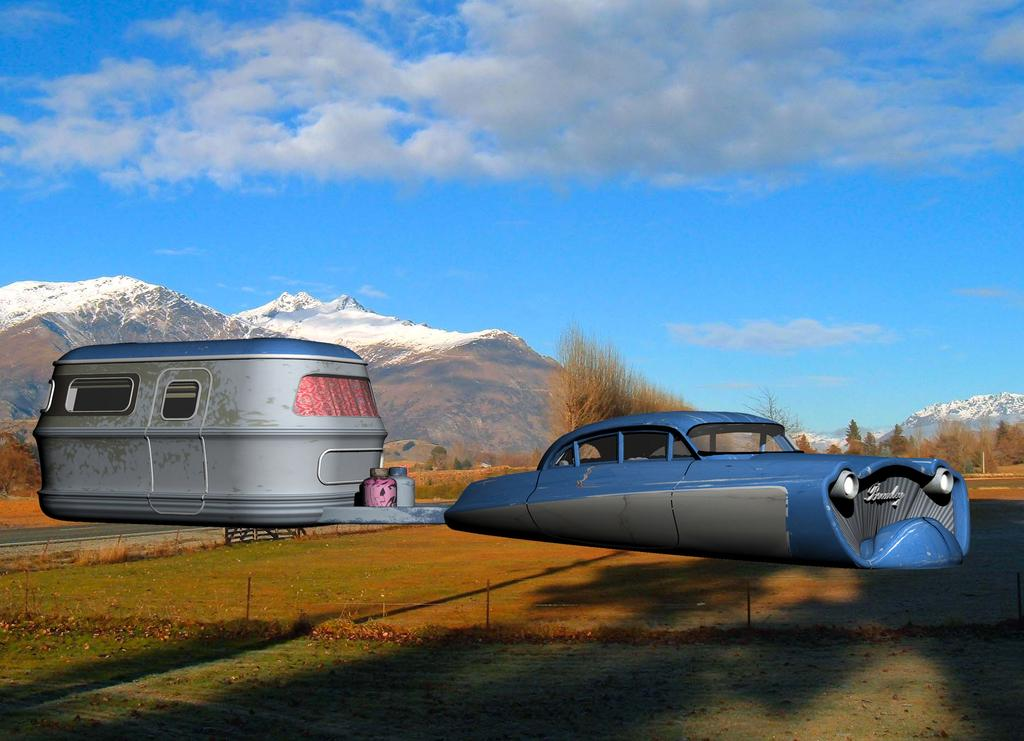What type of vehicles are in the image? There is a car and a van in the image. What can be seen in the background of the image? There are snow-covered mountains in the background of the image. What is visible at the top of the image? The sky is visible at the top of the image. What can be observed in the sky? Clouds are present in the sky. What type of doctor is attending to the pets in the image? There are no doctors or pets present in the image. 